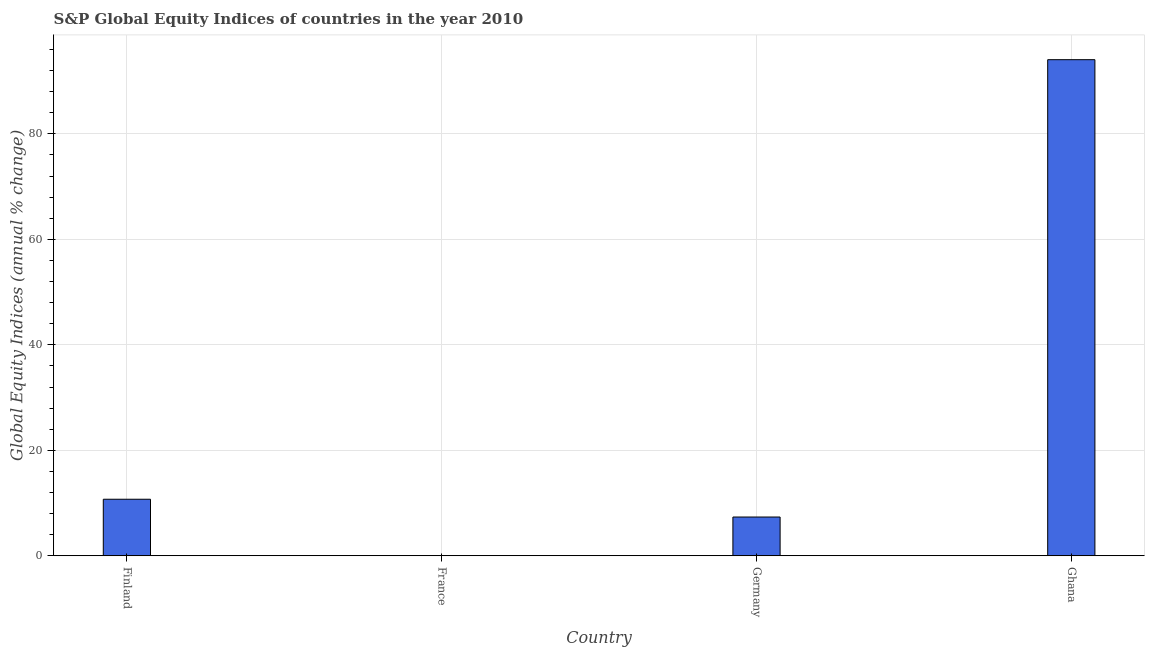Does the graph contain grids?
Your response must be concise. Yes. What is the title of the graph?
Ensure brevity in your answer.  S&P Global Equity Indices of countries in the year 2010. What is the label or title of the Y-axis?
Ensure brevity in your answer.  Global Equity Indices (annual % change). What is the s&p global equity indices in Finland?
Give a very brief answer. 10.72. Across all countries, what is the maximum s&p global equity indices?
Provide a succinct answer. 94.06. Across all countries, what is the minimum s&p global equity indices?
Offer a terse response. 0. In which country was the s&p global equity indices maximum?
Provide a succinct answer. Ghana. What is the sum of the s&p global equity indices?
Your response must be concise. 112.14. What is the difference between the s&p global equity indices in Finland and Ghana?
Give a very brief answer. -83.34. What is the average s&p global equity indices per country?
Offer a very short reply. 28.03. What is the median s&p global equity indices?
Your answer should be very brief. 9.04. In how many countries, is the s&p global equity indices greater than 72 %?
Provide a short and direct response. 1. What is the ratio of the s&p global equity indices in Finland to that in Germany?
Make the answer very short. 1.46. What is the difference between the highest and the second highest s&p global equity indices?
Make the answer very short. 83.34. Is the sum of the s&p global equity indices in Germany and Ghana greater than the maximum s&p global equity indices across all countries?
Offer a very short reply. Yes. What is the difference between the highest and the lowest s&p global equity indices?
Ensure brevity in your answer.  94.06. How many bars are there?
Give a very brief answer. 3. Are all the bars in the graph horizontal?
Your response must be concise. No. What is the difference between two consecutive major ticks on the Y-axis?
Provide a short and direct response. 20. Are the values on the major ticks of Y-axis written in scientific E-notation?
Provide a short and direct response. No. What is the Global Equity Indices (annual % change) of Finland?
Provide a short and direct response. 10.72. What is the Global Equity Indices (annual % change) in Germany?
Keep it short and to the point. 7.35. What is the Global Equity Indices (annual % change) of Ghana?
Your answer should be very brief. 94.06. What is the difference between the Global Equity Indices (annual % change) in Finland and Germany?
Your response must be concise. 3.37. What is the difference between the Global Equity Indices (annual % change) in Finland and Ghana?
Give a very brief answer. -83.34. What is the difference between the Global Equity Indices (annual % change) in Germany and Ghana?
Your response must be concise. -86.71. What is the ratio of the Global Equity Indices (annual % change) in Finland to that in Germany?
Keep it short and to the point. 1.46. What is the ratio of the Global Equity Indices (annual % change) in Finland to that in Ghana?
Give a very brief answer. 0.11. What is the ratio of the Global Equity Indices (annual % change) in Germany to that in Ghana?
Your answer should be compact. 0.08. 